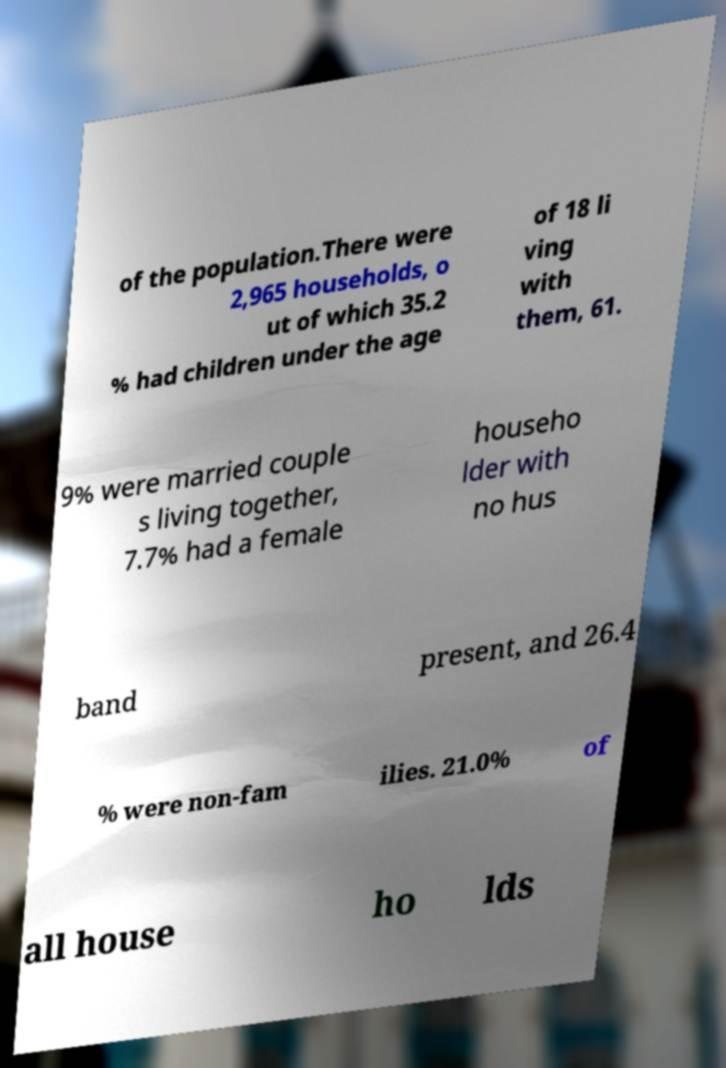I need the written content from this picture converted into text. Can you do that? of the population.There were 2,965 households, o ut of which 35.2 % had children under the age of 18 li ving with them, 61. 9% were married couple s living together, 7.7% had a female househo lder with no hus band present, and 26.4 % were non-fam ilies. 21.0% of all house ho lds 